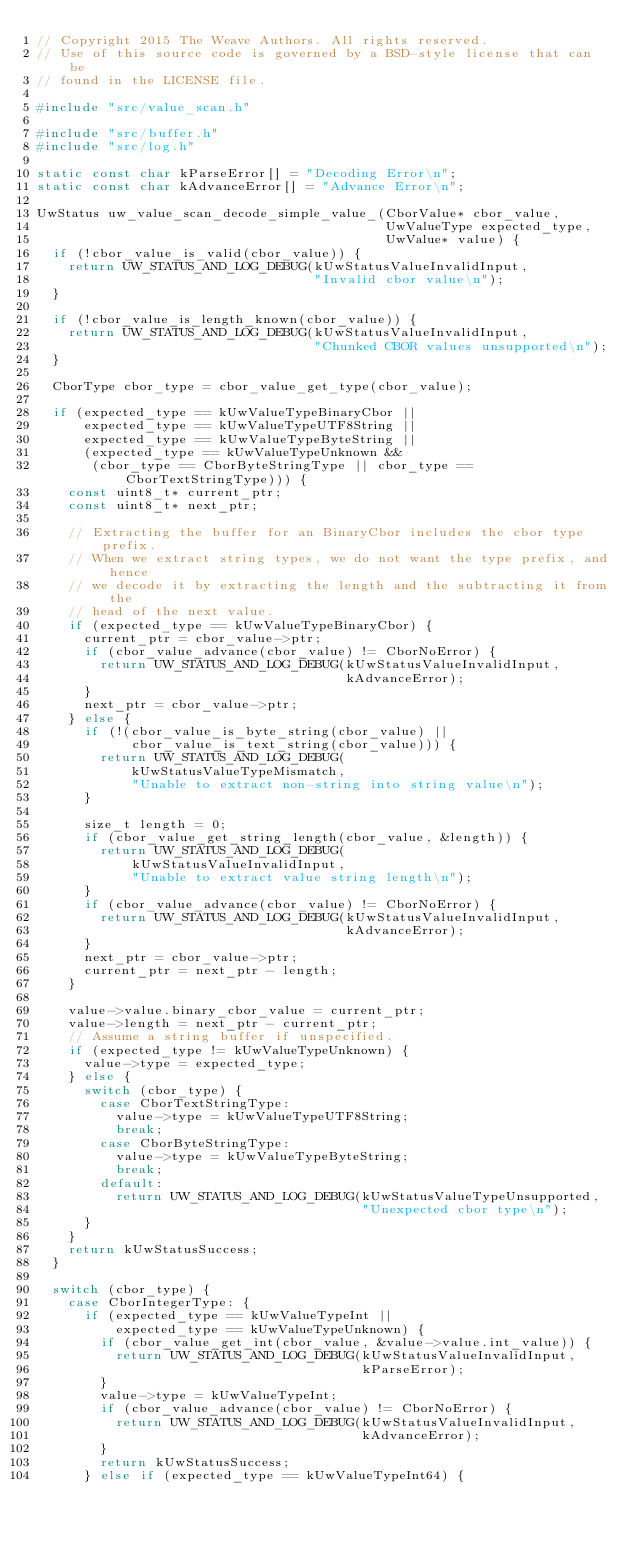<code> <loc_0><loc_0><loc_500><loc_500><_C_>// Copyright 2015 The Weave Authors. All rights reserved.
// Use of this source code is governed by a BSD-style license that can be
// found in the LICENSE file.

#include "src/value_scan.h"

#include "src/buffer.h"
#include "src/log.h"

static const char kParseError[] = "Decoding Error\n";
static const char kAdvanceError[] = "Advance Error\n";

UwStatus uw_value_scan_decode_simple_value_(CborValue* cbor_value,
                                            UwValueType expected_type,
                                            UwValue* value) {
  if (!cbor_value_is_valid(cbor_value)) {
    return UW_STATUS_AND_LOG_DEBUG(kUwStatusValueInvalidInput,
                                   "Invalid cbor value\n");
  }

  if (!cbor_value_is_length_known(cbor_value)) {
    return UW_STATUS_AND_LOG_DEBUG(kUwStatusValueInvalidInput,
                                   "Chunked CBOR values unsupported\n");
  }

  CborType cbor_type = cbor_value_get_type(cbor_value);

  if (expected_type == kUwValueTypeBinaryCbor ||
      expected_type == kUwValueTypeUTF8String ||
      expected_type == kUwValueTypeByteString ||
      (expected_type == kUwValueTypeUnknown &&
       (cbor_type == CborByteStringType || cbor_type == CborTextStringType))) {
    const uint8_t* current_ptr;
    const uint8_t* next_ptr;

    // Extracting the buffer for an BinaryCbor includes the cbor type prefix.
    // When we extract string types, we do not want the type prefix, and hence
    // we decode it by extracting the length and the subtracting it from the
    // head of the next value.
    if (expected_type == kUwValueTypeBinaryCbor) {
      current_ptr = cbor_value->ptr;
      if (cbor_value_advance(cbor_value) != CborNoError) {
        return UW_STATUS_AND_LOG_DEBUG(kUwStatusValueInvalidInput,
                                       kAdvanceError);
      }
      next_ptr = cbor_value->ptr;
    } else {
      if (!(cbor_value_is_byte_string(cbor_value) ||
            cbor_value_is_text_string(cbor_value))) {
        return UW_STATUS_AND_LOG_DEBUG(
            kUwStatusValueTypeMismatch,
            "Unable to extract non-string into string value\n");
      }

      size_t length = 0;
      if (cbor_value_get_string_length(cbor_value, &length)) {
        return UW_STATUS_AND_LOG_DEBUG(
            kUwStatusValueInvalidInput,
            "Unable to extract value string length\n");
      }
      if (cbor_value_advance(cbor_value) != CborNoError) {
        return UW_STATUS_AND_LOG_DEBUG(kUwStatusValueInvalidInput,
                                       kAdvanceError);
      }
      next_ptr = cbor_value->ptr;
      current_ptr = next_ptr - length;
    }

    value->value.binary_cbor_value = current_ptr;
    value->length = next_ptr - current_ptr;
    // Assume a string buffer if unspecified.
    if (expected_type != kUwValueTypeUnknown) {
      value->type = expected_type;
    } else {
      switch (cbor_type) {
        case CborTextStringType:
          value->type = kUwValueTypeUTF8String;
          break;
        case CborByteStringType:
          value->type = kUwValueTypeByteString;
          break;
        default:
          return UW_STATUS_AND_LOG_DEBUG(kUwStatusValueTypeUnsupported,
                                         "Unexpected cbor type\n");
      }
    }
    return kUwStatusSuccess;
  }

  switch (cbor_type) {
    case CborIntegerType: {
      if (expected_type == kUwValueTypeInt ||
          expected_type == kUwValueTypeUnknown) {
        if (cbor_value_get_int(cbor_value, &value->value.int_value)) {
          return UW_STATUS_AND_LOG_DEBUG(kUwStatusValueInvalidInput,
                                         kParseError);
        }
        value->type = kUwValueTypeInt;
        if (cbor_value_advance(cbor_value) != CborNoError) {
          return UW_STATUS_AND_LOG_DEBUG(kUwStatusValueInvalidInput,
                                         kAdvanceError);
        }
        return kUwStatusSuccess;
      } else if (expected_type == kUwValueTypeInt64) {</code> 